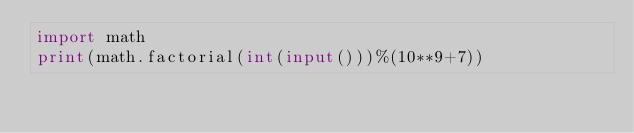Convert code to text. <code><loc_0><loc_0><loc_500><loc_500><_Python_>import math
print(math.factorial(int(input()))%(10**9+7))</code> 